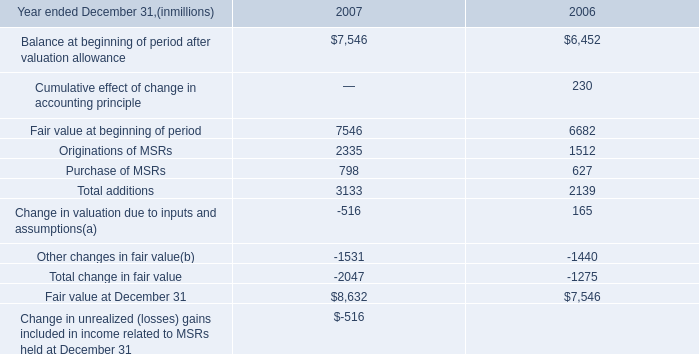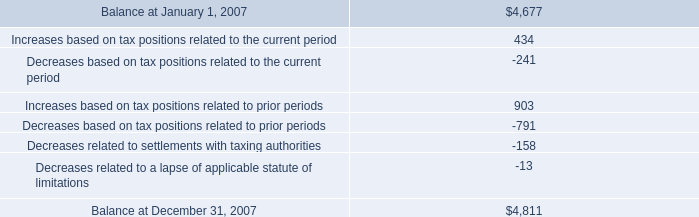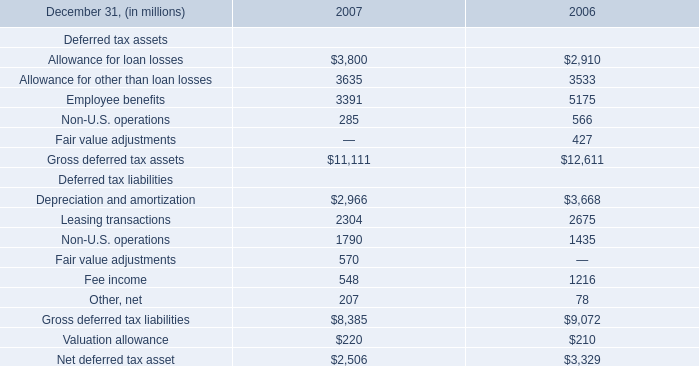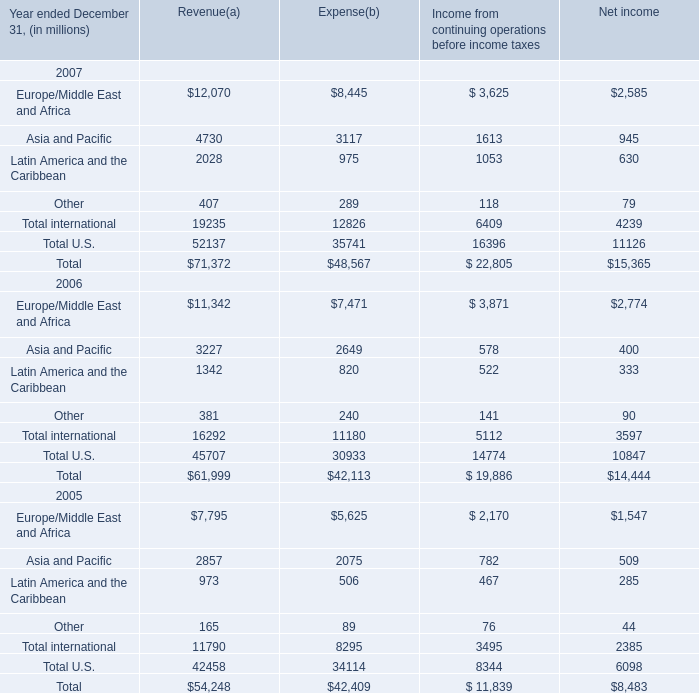What is the average amount of Other changes in fair value of 2006, and Balance at January 1, 2007 ? 
Computations: ((1440.0 + 4677.0) / 2)
Answer: 3058.5. 